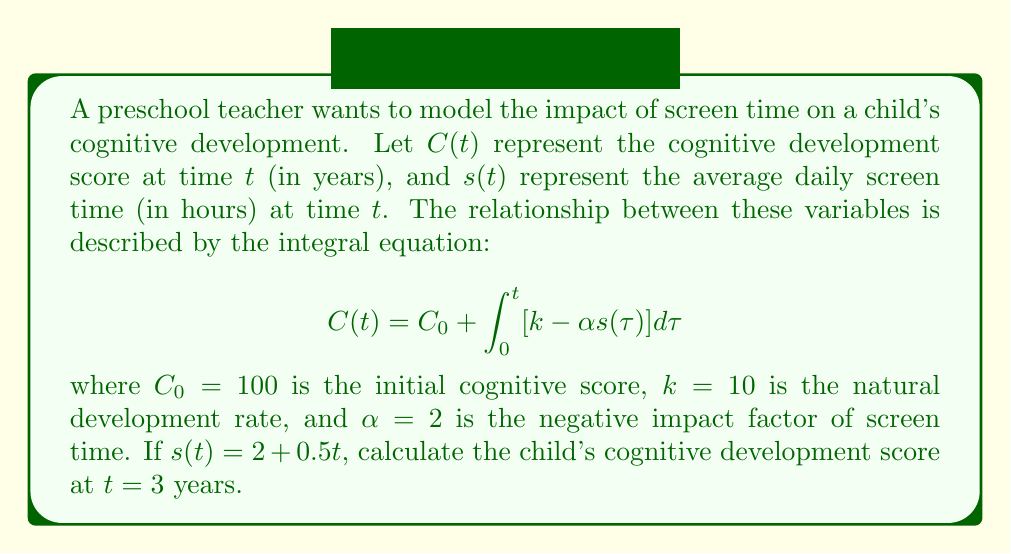Could you help me with this problem? Let's solve this problem step by step:

1) We are given the integral equation:
   $$C(t) = C_0 + \int_0^t [k - \alpha s(\tau)] d\tau$$

2) We know the following values:
   $C_0 = 100$
   $k = 10$
   $\alpha = 2$
   $s(t) = 2 + 0.5t$
   We need to find $C(3)$

3) Let's substitute these values into the equation:
   $$C(3) = 100 + \int_0^3 [10 - 2(2 + 0.5\tau)] d\tau$$

4) Simplify the integrand:
   $$C(3) = 100 + \int_0^3 [10 - 4 - \tau] d\tau = 100 + \int_0^3 [6 - \tau] d\tau$$

5) Now we can integrate:
   $$C(3) = 100 + [6\tau - \frac{\tau^2}{2}]_0^3$$

6) Evaluate the integral:
   $$C(3) = 100 + [(6 \cdot 3 - \frac{3^2}{2}) - (6 \cdot 0 - \frac{0^2}{2})]$$

7) Simplify:
   $$C(3) = 100 + [18 - 4.5 - 0] = 100 + 13.5 = 113.5$$

Therefore, the child's cognitive development score at $t = 3$ years is 113.5.
Answer: 113.5 